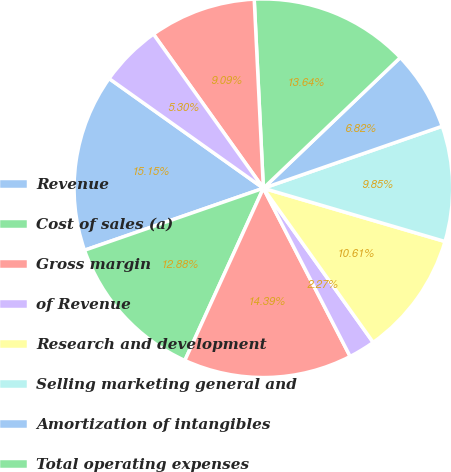Convert chart. <chart><loc_0><loc_0><loc_500><loc_500><pie_chart><fcel>Revenue<fcel>Cost of sales (a)<fcel>Gross margin<fcel>of Revenue<fcel>Research and development<fcel>Selling marketing general and<fcel>Amortization of intangibles<fcel>Total operating expenses<fcel>Operating income<fcel>Interest expense<nl><fcel>15.15%<fcel>12.88%<fcel>14.39%<fcel>2.27%<fcel>10.61%<fcel>9.85%<fcel>6.82%<fcel>13.64%<fcel>9.09%<fcel>5.3%<nl></chart> 